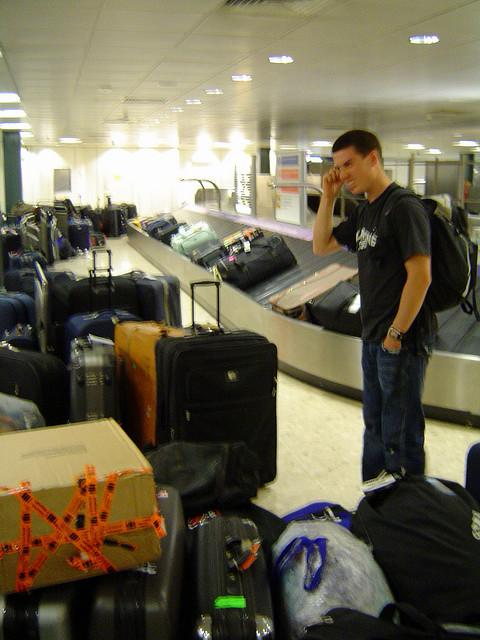What kind of reaction the person shows? confusion 